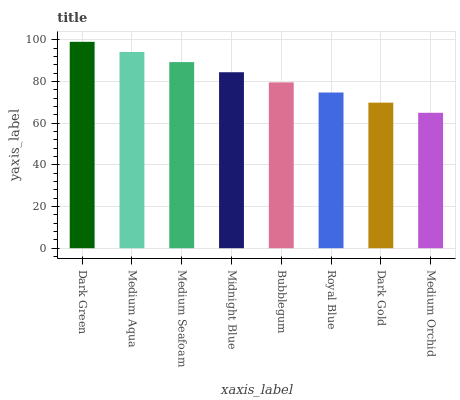Is Medium Orchid the minimum?
Answer yes or no. Yes. Is Dark Green the maximum?
Answer yes or no. Yes. Is Medium Aqua the minimum?
Answer yes or no. No. Is Medium Aqua the maximum?
Answer yes or no. No. Is Dark Green greater than Medium Aqua?
Answer yes or no. Yes. Is Medium Aqua less than Dark Green?
Answer yes or no. Yes. Is Medium Aqua greater than Dark Green?
Answer yes or no. No. Is Dark Green less than Medium Aqua?
Answer yes or no. No. Is Midnight Blue the high median?
Answer yes or no. Yes. Is Bubblegum the low median?
Answer yes or no. Yes. Is Bubblegum the high median?
Answer yes or no. No. Is Dark Green the low median?
Answer yes or no. No. 